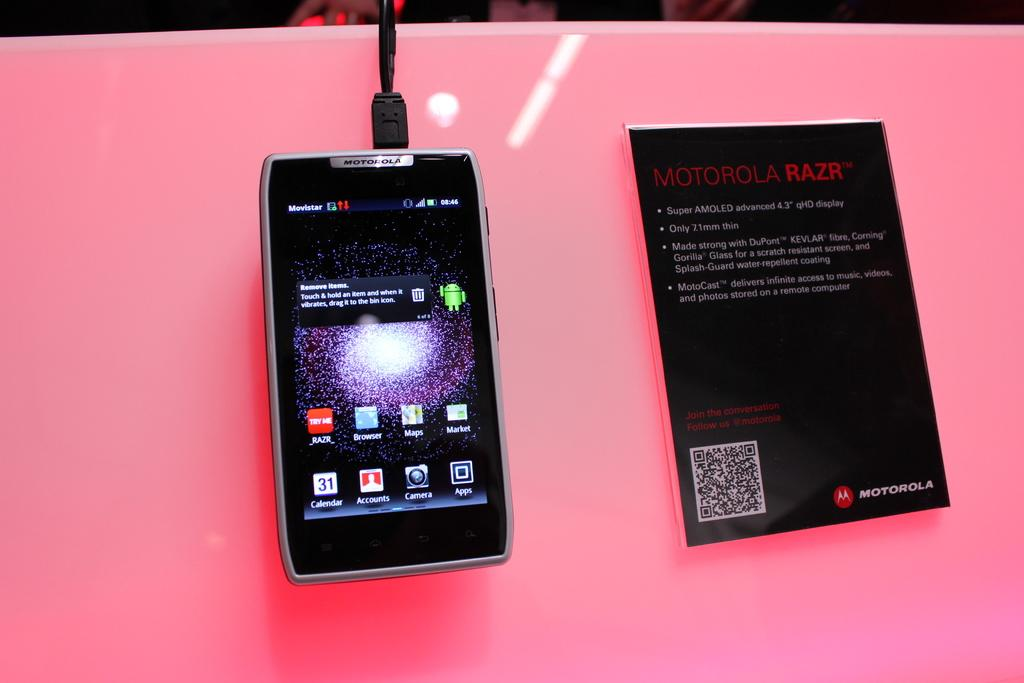<image>
Create a compact narrative representing the image presented. A phone is displayed next to a sign describing motorola razr 